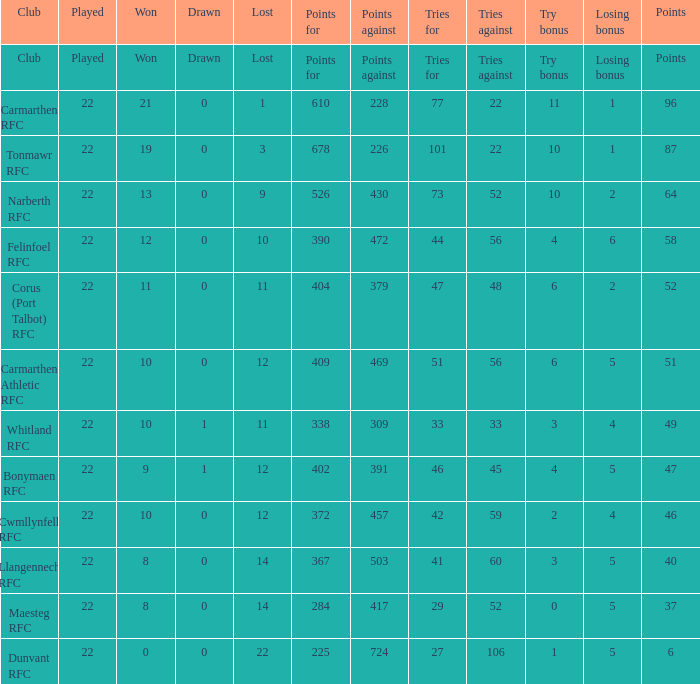State the negatives for 51 points. 469.0. 